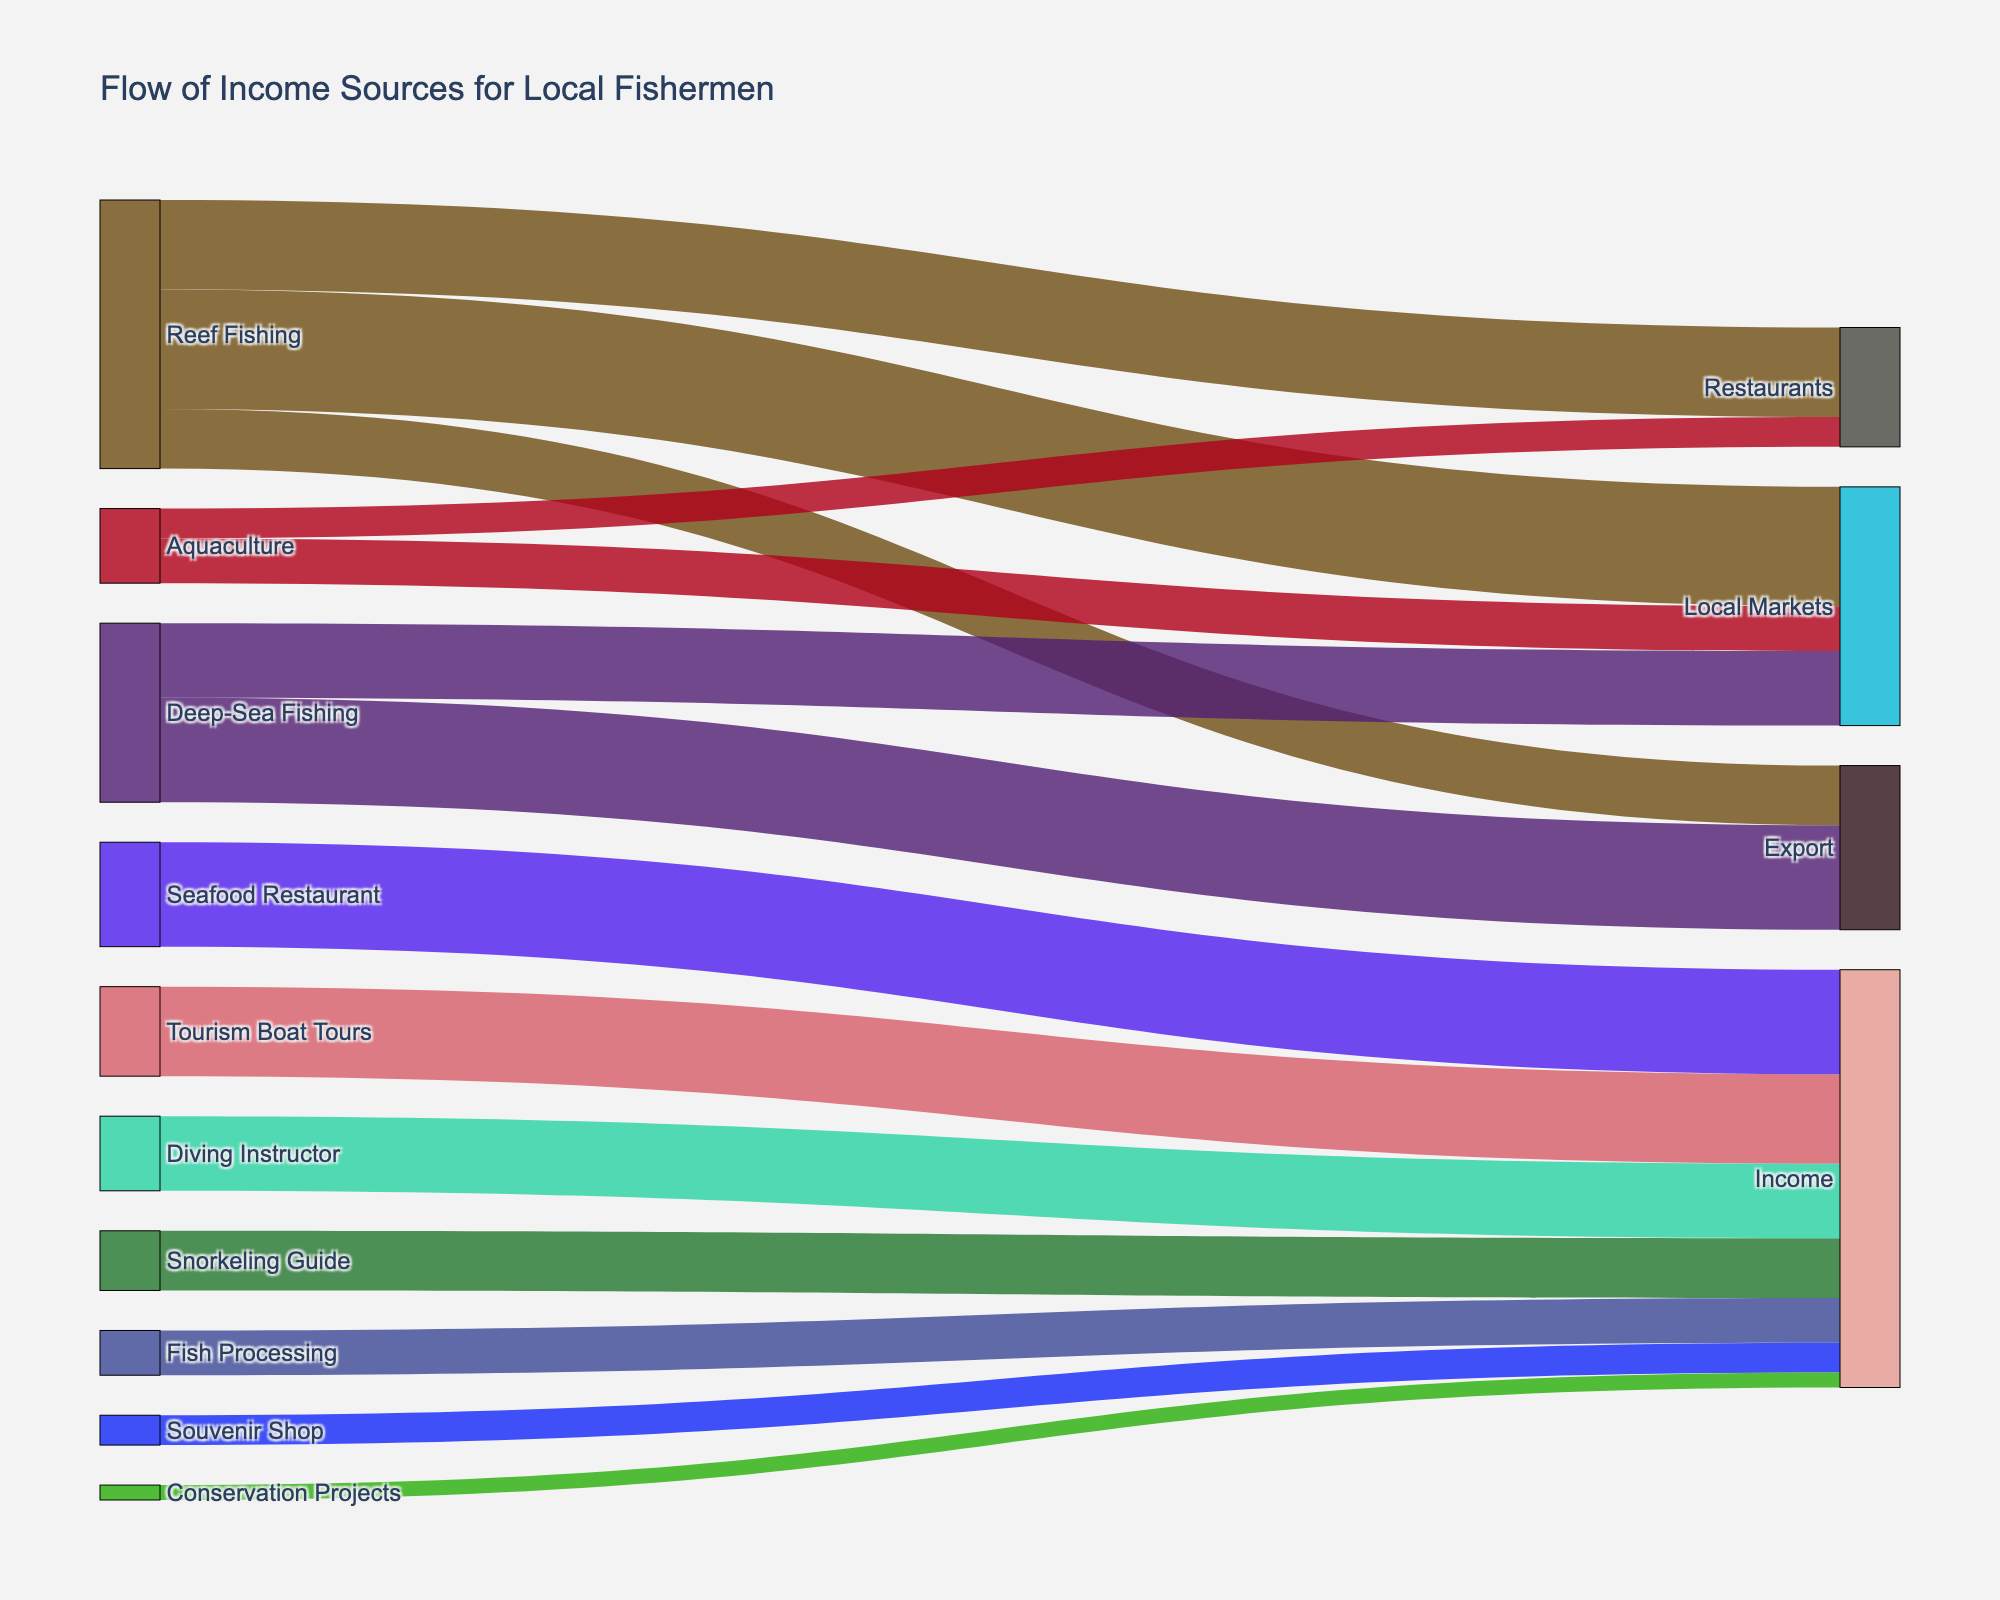What's the total income from activities related to tourism? To find the total income from tourism-related activities, sum the values corresponding to "Tourism Boat Tours", "Snorkeling Guide", "Diving Instructor", "Seafood Restaurant", "Fish Processing", "Souvenir Shop", and "Conservation Projects". The values are 30, 20, 25, 35, 15, 10, and 5 respectively. Thus, the total income is 30 + 20 + 25 + 35 + 15 + 10 + 5 = 140
Answer: 140 Which activity has the highest income contribution from tourism? Evaluate the values for each tourism-related activity. "Seafood Restaurant" has an income of 35, which is the highest among tourism-related activities like "Tourism Boat Tours" (30), "Snorkeling Guide" (20), "Diving Instructor" (25), "Fish Processing" (15), "Souvenir Shop" (10), and "Conservation Projects" (5).
Answer: Seafood Restaurant What is the sum of income from Reef Fishing to Local Markets and Restaurants combined? Sum the values for "Reef Fishing" to "Local Markets" (40) and "Reef Fishing" to "Restaurants" (30). The sum is 40 + 30 = 70
Answer: 70 How does the income from Aquaculture to Local Markets compare to that of Deep-Sea Fishing to Local Markets? "Aquaculture" to "Local Markets" has an income of 15, whereas "Deep-Sea Fishing" to "Local Markets" has an income of 25. Compare these values: 15 < 25.
Answer: Deep-Sea Fishing to Local Markets has a higher income What percentage of Reef Fishing income goes to Export? Sum all income sources of “Reef Fishing” to get the total: 40 (Local Markets) + 30 (Restaurants) + 20 (Export) = 90. The percentage going to Export is calculated as (20 / 90) * 100.
Answer: 22.22% What is the difference in income between Deep-Sea Fishing to Export and Reef Fishing to Export? Find the income from "Deep-Sea Fishing" to "Export" (35) and "Reef Fishing" to "Export" (20). The difference is 35 - 20 = 15
Answer: 15 Which income source contributes the least among all activities? Observe the smallest value among all the activities. "Conservation Projects" have the lowest value of 5.
Answer: Conservation Projects What total value goes to Local Markets from all fishing-related sources? Sum the values for all the sources leading to "Local Markets": "Reef Fishing" (40), "Deep-Sea Fishing" (25), "Aquaculture" (15). The total is 40 + 25 + 15 = 80
Answer: 80 How does the combined income from Snorkeling Guide and Diving Instructor compare to the income from Seafood Restaurant? The combined income of "Snorkeling Guide" (20) and "Diving Instructor" (25) is 20 + 25 = 45. Compare this to "Seafood Restaurant" (35).
Answer: The combined income (45) is greater than Seafood Restaurant (35) 